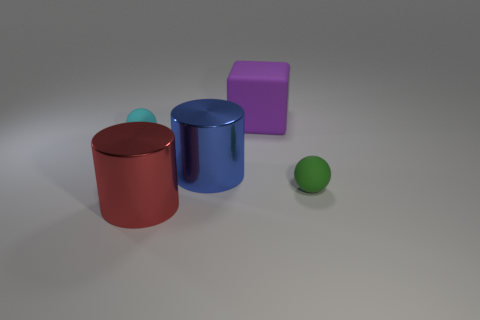If these objects were part of a game, what could be their possible functions? In a game setting, these objects could serve various functions: the large blue object might be a container or a barrel for storing items, the red cylinder could act as a puzzle element that needs to be moved to specific locations, the green sphere might be a collectible or a power-up, and the tiny cyan sphere could be a trigger or a key for unlocking new areas or mechanisms. 